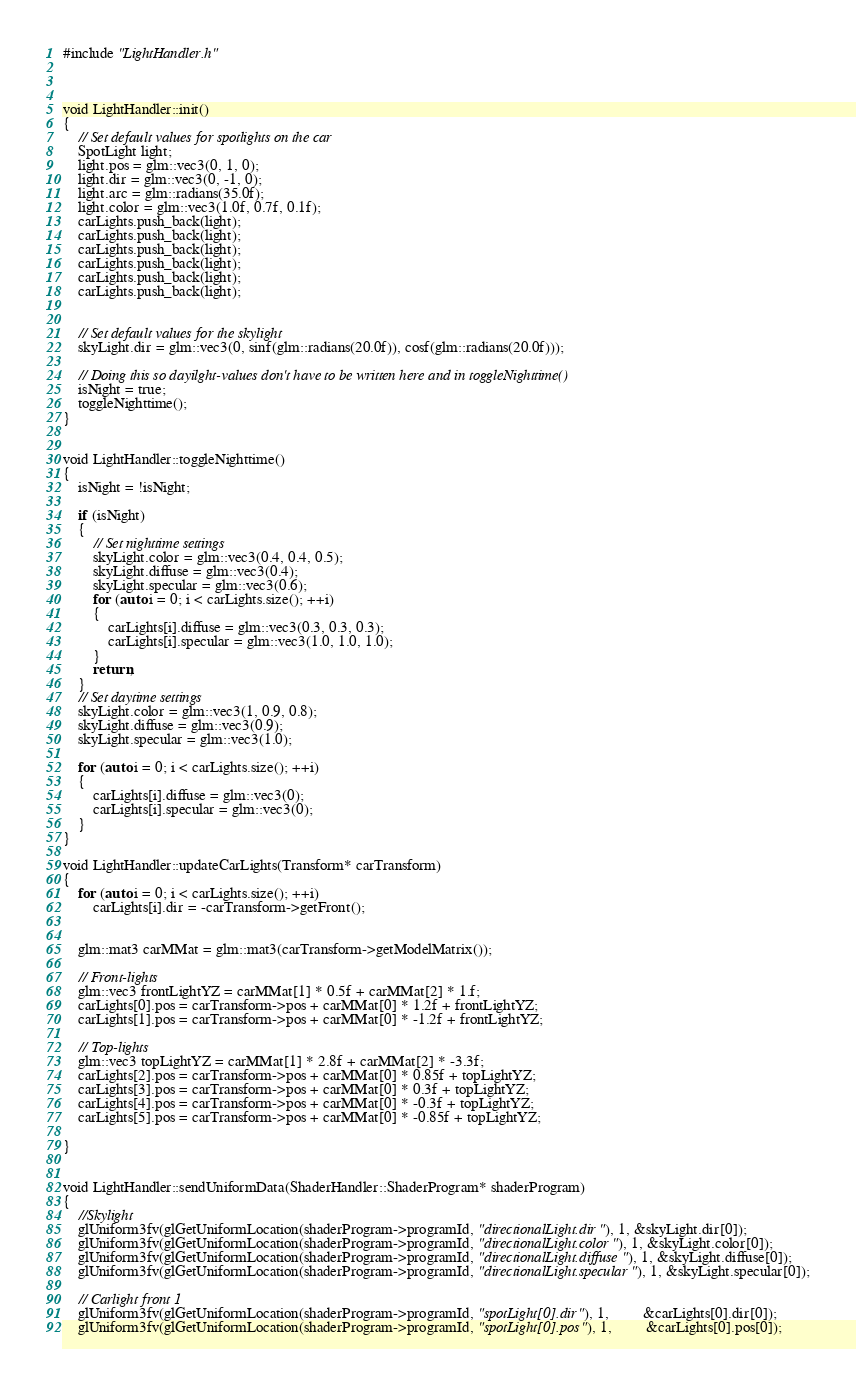<code> <loc_0><loc_0><loc_500><loc_500><_C++_>#include "LightHandler.h"



void LightHandler::init()
{
	// Set default values for spotlights on the car
	SpotLight light;
	light.pos = glm::vec3(0, 1, 0);
	light.dir = glm::vec3(0, -1, 0);
	light.arc = glm::radians(35.0f);
	light.color = glm::vec3(1.0f, 0.7f, 0.1f);
	carLights.push_back(light);
	carLights.push_back(light);
	carLights.push_back(light);
	carLights.push_back(light);
	carLights.push_back(light);
	carLights.push_back(light);


	// Set default values for the skylight
	skyLight.dir = glm::vec3(0, sinf(glm::radians(20.0f)), cosf(glm::radians(20.0f)));

	// Doing this so dayilght-values don't have to be written here and in toggleNighttime()
	isNight = true;
	toggleNighttime();
}


void LightHandler::toggleNighttime()
{
	isNight = !isNight;

	if (isNight)
	{
		// Set nighttime settings
		skyLight.color = glm::vec3(0.4, 0.4, 0.5);
		skyLight.diffuse = glm::vec3(0.4);
		skyLight.specular = glm::vec3(0.6);
		for (auto i = 0; i < carLights.size(); ++i)
		{
			carLights[i].diffuse = glm::vec3(0.3, 0.3, 0.3);
			carLights[i].specular = glm::vec3(1.0, 1.0, 1.0);
		}
		return;
	}
	// Set daytime settings
	skyLight.color = glm::vec3(1, 0.9, 0.8);
	skyLight.diffuse = glm::vec3(0.9);
	skyLight.specular = glm::vec3(1.0);

	for (auto i = 0; i < carLights.size(); ++i)
	{
		carLights[i].diffuse = glm::vec3(0); 
		carLights[i].specular = glm::vec3(0);
	}
}

void LightHandler::updateCarLights(Transform* carTransform)
{
	for (auto i = 0; i < carLights.size(); ++i)
		carLights[i].dir = -carTransform->getFront();


	glm::mat3 carMMat = glm::mat3(carTransform->getModelMatrix());
	
	// Front-lights
	glm::vec3 frontLightYZ = carMMat[1] * 0.5f + carMMat[2] * 1.f;
	carLights[0].pos = carTransform->pos + carMMat[0] * 1.2f + frontLightYZ;
	carLights[1].pos = carTransform->pos + carMMat[0] * -1.2f + frontLightYZ;

	// Top-lights
	glm::vec3 topLightYZ = carMMat[1] * 2.8f + carMMat[2] * -3.3f;
	carLights[2].pos = carTransform->pos + carMMat[0] * 0.85f + topLightYZ;
	carLights[3].pos = carTransform->pos + carMMat[0] * 0.3f + topLightYZ;
	carLights[4].pos = carTransform->pos + carMMat[0] * -0.3f + topLightYZ;
	carLights[5].pos = carTransform->pos + carMMat[0] * -0.85f + topLightYZ;

}


void LightHandler::sendUniformData(ShaderHandler::ShaderProgram* shaderProgram)
{
	//Skylight
	glUniform3fv(glGetUniformLocation(shaderProgram->programId, "directionalLight.dir"), 1, &skyLight.dir[0]);
	glUniform3fv(glGetUniformLocation(shaderProgram->programId, "directionalLight.color"), 1, &skyLight.color[0]);
	glUniform3fv(glGetUniformLocation(shaderProgram->programId, "directionalLight.diffuse"), 1, &skyLight.diffuse[0]);
	glUniform3fv(glGetUniformLocation(shaderProgram->programId, "directionalLight.specular"), 1, &skyLight.specular[0]);

	// Carlight front 1
	glUniform3fv(glGetUniformLocation(shaderProgram->programId, "spotLight[0].dir"), 1,		 &carLights[0].dir[0]);
	glUniform3fv(glGetUniformLocation(shaderProgram->programId, "spotLight[0].pos"), 1,		 &carLights[0].pos[0]);</code> 